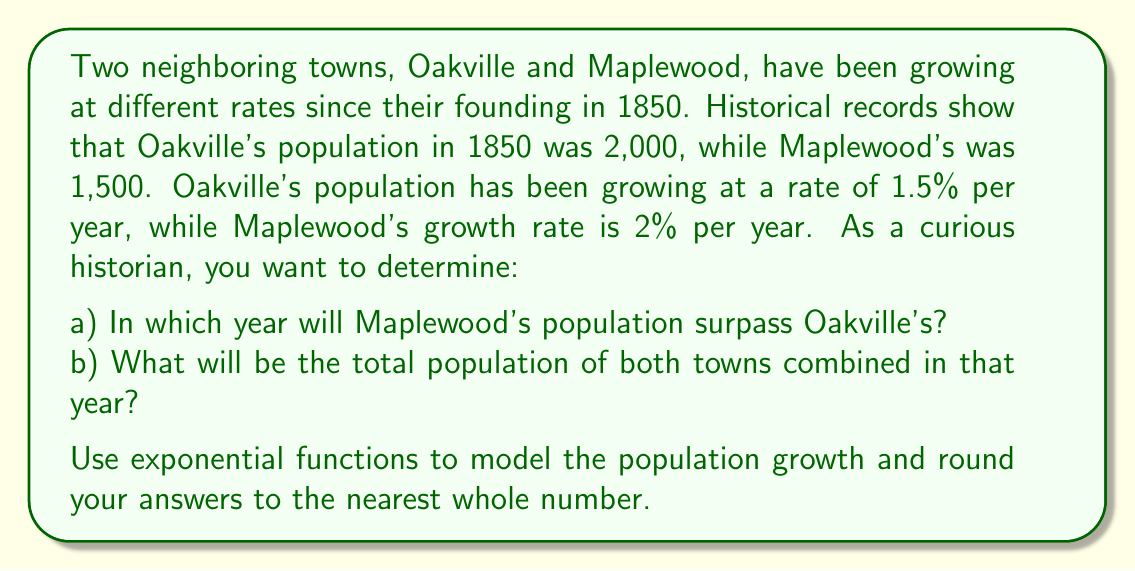What is the answer to this math problem? Let's approach this problem step-by-step:

1) First, we need to set up exponential functions for each town's population growth:

   For Oakville: $P_O(t) = 2000(1.015)^t$
   For Maplewood: $P_M(t) = 1500(1.02)^t$

   Where $t$ is the number of years since 1850.

2) To find when Maplewood's population surpasses Oakville's, we need to solve:

   $1500(1.02)^t = 2000(1.015)^t$

3) We can solve this equation by taking the natural logarithm of both sides:

   $\ln(1500) + t\ln(1.02) = \ln(2000) + t\ln(1.015)$

4) Rearranging the equation:

   $t(\ln(1.02) - \ln(1.015)) = \ln(2000) - \ln(1500)$

5) Solving for $t$:

   $t = \frac{\ln(2000) - \ln(1500)}{\ln(1.02) - \ln(1.015)} \approx 97.62$

6) Rounding up to the nearest whole number, we get 98 years. This means Maplewood will surpass Oakville in 1948.

7) To find the total population in 1948, we calculate:

   Oakville: $P_O(98) = 2000(1.015)^{98} \approx 8,186$
   Maplewood: $P_M(98) = 1500(1.02)^{98} \approx 8,210$

8) The total population is the sum of these two values:

   Total population = 8,186 + 8,210 = 16,396
Answer: a) Maplewood's population will surpass Oakville's in 1948 (98 years after 1850).
b) The total population of both towns combined in 1948 will be 16,396. 